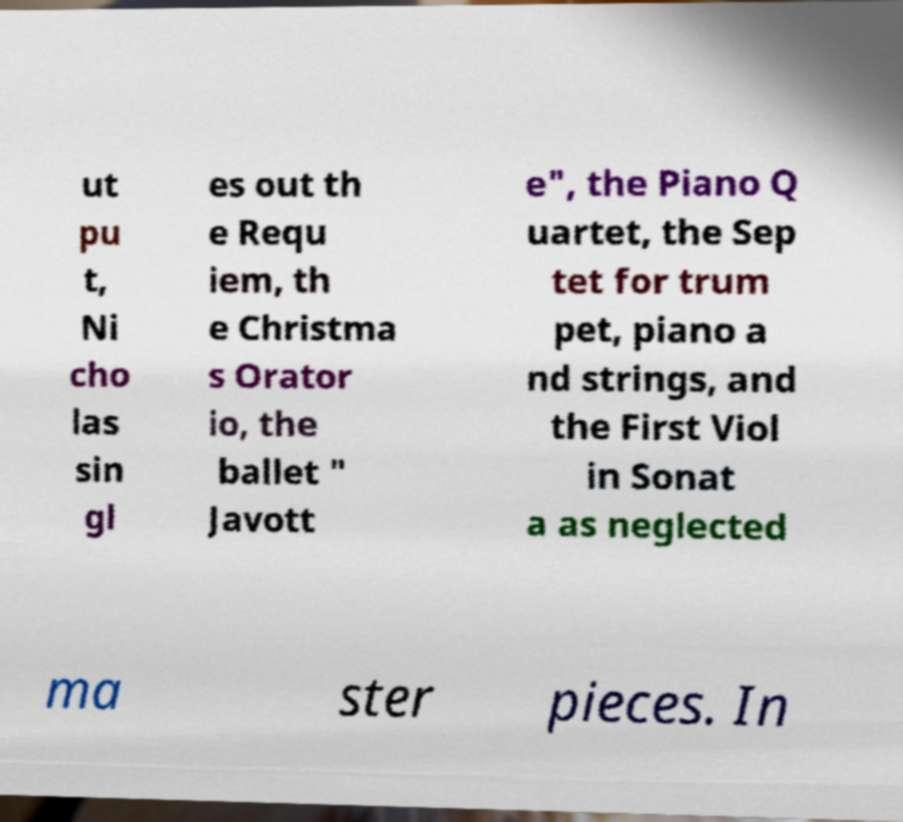What messages or text are displayed in this image? I need them in a readable, typed format. ut pu t, Ni cho las sin gl es out th e Requ iem, th e Christma s Orator io, the ballet " Javott e", the Piano Q uartet, the Sep tet for trum pet, piano a nd strings, and the First Viol in Sonat a as neglected ma ster pieces. In 